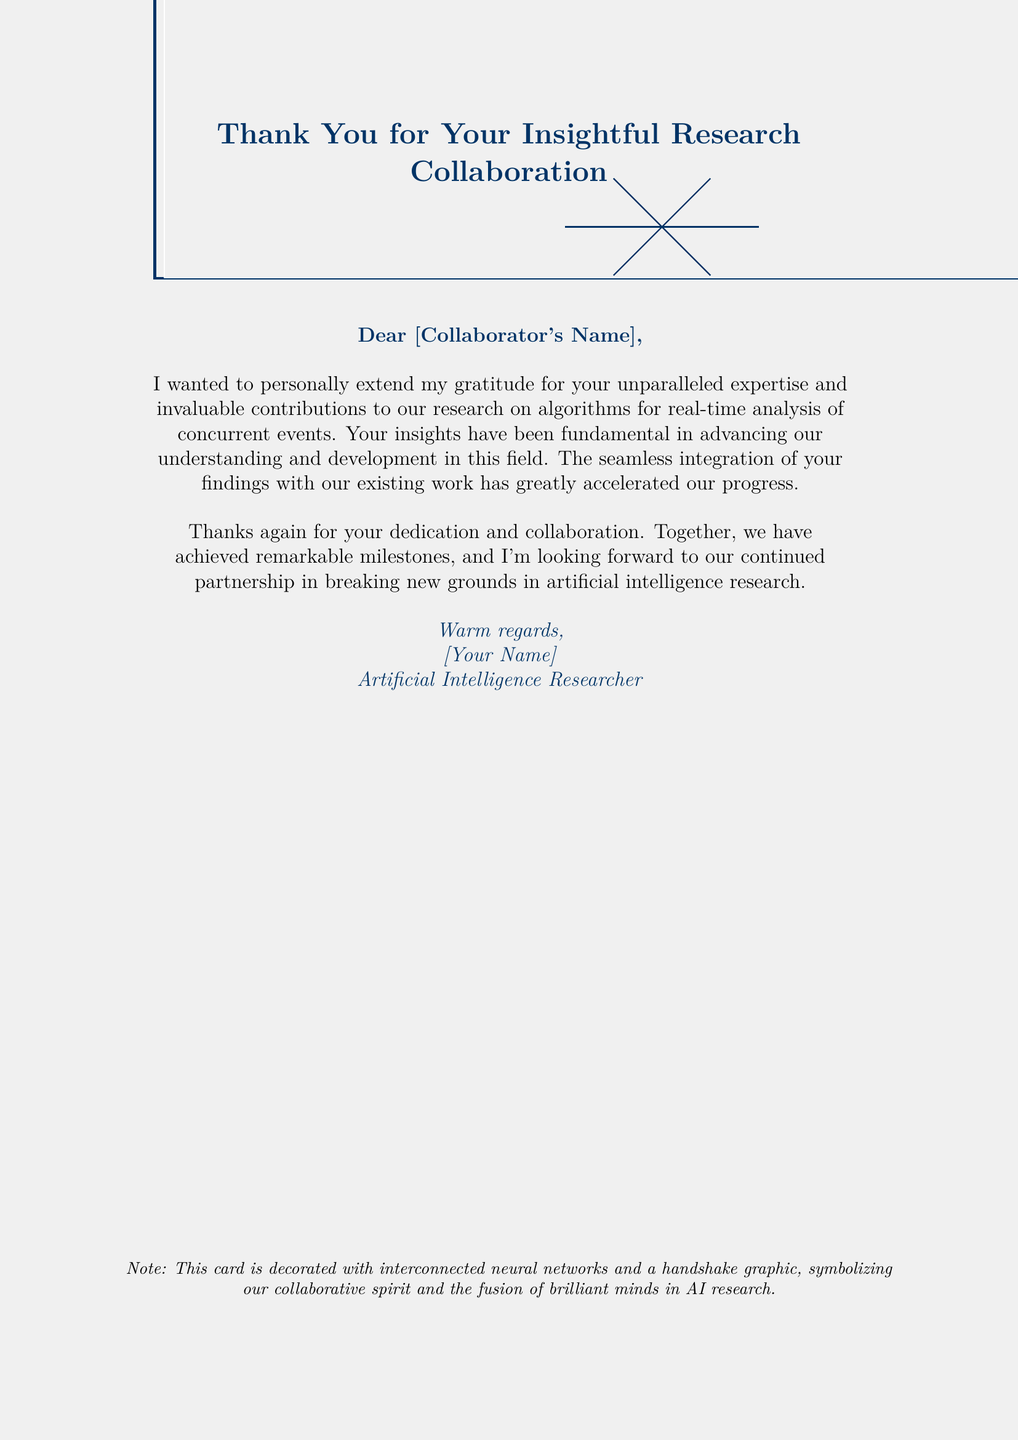What is the title of the greeting card? The title is prominently displayed at the top of the card, expressing gratitude for collaboration in research.
Answer: Thank You for Your Insightful Research Collaboration Who is the card addressed to? The salutation in the document indicates that it is addressed to a specific collaborator whose name can be filled in.
Answer: [Collaborator's Name] What is the main focus of the research collaboration mentioned? The document highlights the specific area of research that the collaboration pertains to, which is stated explicitly.
Answer: algorithms for real-time analysis of concurrent events What color is used for the main text in the greeting card? The color of the text used throughout the card is described at the start of the document.
Answer: deepblue How is the card decorated? The document mentions specific visual elements that decorate the card, which symbolize collaboration.
Answer: interconnected neural networks and a handshake graphic What type of graphic symbolizes collaboration in the card? According to the note at the bottom of the card, this graphic represents the spirit of teamwork in research.
Answer: handshake graphic How does the sender express gratitude in the card? The specific wording shows appreciation for the contributions and insights provided by the collaborator.
Answer: unparalleled expertise and invaluable contributions What does the sender look forward to after this collaboration? The document indicates the future intentions of the sender regarding their work together.
Answer: continued partnership in breaking new grounds in artificial intelligence research What phrase characterizes the relationship between the sender and the recipient? The document uses specific words to convey the nature of their collaborative relationship.
Answer: collaborative spirit 